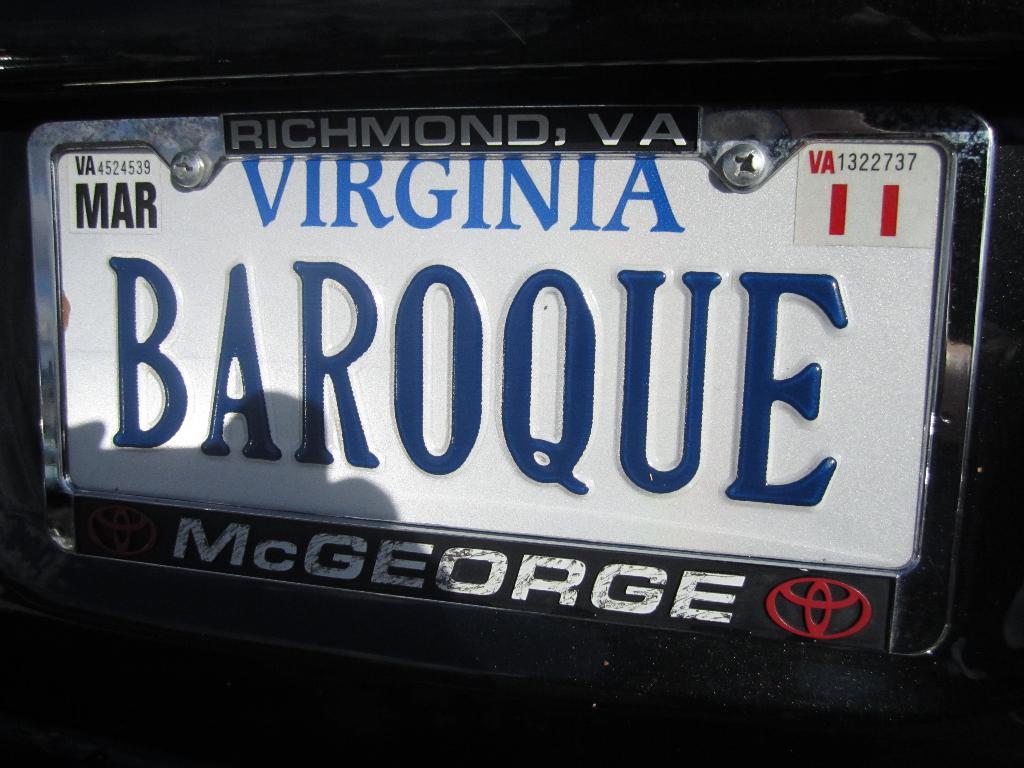What word is shown in dark blue text?
Make the answer very short. Baroque. Is mcgeorge an auto retailer?
Your response must be concise. Yes. 